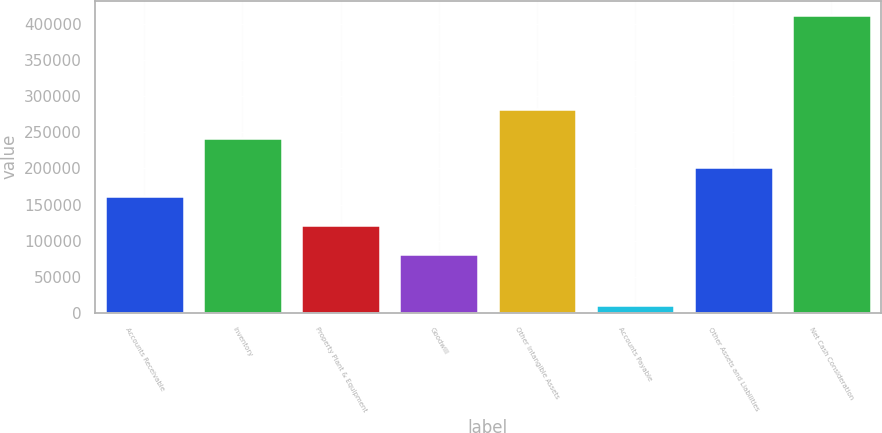Convert chart. <chart><loc_0><loc_0><loc_500><loc_500><bar_chart><fcel>Accounts Receivable<fcel>Inventory<fcel>Property Plant & Equipment<fcel>Goodwill<fcel>Other Intangible Assets<fcel>Accounts Payable<fcel>Other Assets and Liabilities<fcel>Net Cash Consideration<nl><fcel>162019<fcel>242179<fcel>121939<fcel>81859<fcel>282260<fcel>10993<fcel>202099<fcel>411794<nl></chart> 